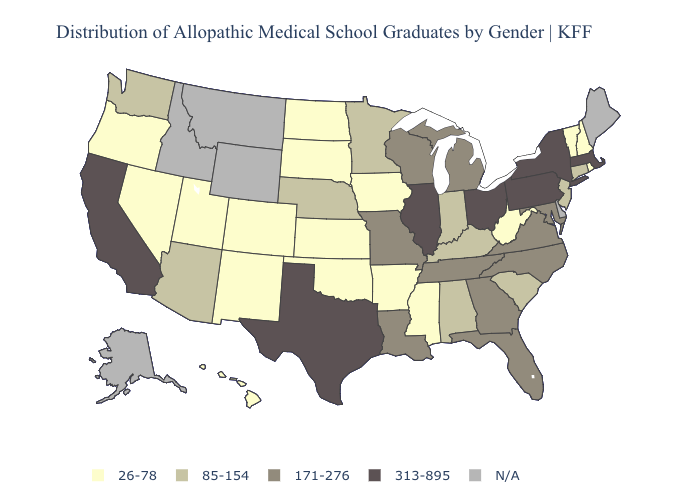What is the value of Michigan?
Short answer required. 171-276. Among the states that border Michigan , does Ohio have the highest value?
Give a very brief answer. Yes. What is the highest value in states that border New Hampshire?
Be succinct. 313-895. Name the states that have a value in the range N/A?
Quick response, please. Alaska, Delaware, Idaho, Maine, Montana, Wyoming. What is the lowest value in states that border Nebraska?
Short answer required. 26-78. Does New Jersey have the lowest value in the USA?
Concise answer only. No. What is the lowest value in the USA?
Write a very short answer. 26-78. What is the value of California?
Quick response, please. 313-895. Name the states that have a value in the range 26-78?
Answer briefly. Arkansas, Colorado, Hawaii, Iowa, Kansas, Mississippi, Nevada, New Hampshire, New Mexico, North Dakota, Oklahoma, Oregon, Rhode Island, South Dakota, Utah, Vermont, West Virginia. Name the states that have a value in the range N/A?
Be succinct. Alaska, Delaware, Idaho, Maine, Montana, Wyoming. Name the states that have a value in the range 171-276?
Quick response, please. Florida, Georgia, Louisiana, Maryland, Michigan, Missouri, North Carolina, Tennessee, Virginia, Wisconsin. What is the value of North Dakota?
Short answer required. 26-78. What is the value of Montana?
Concise answer only. N/A. Does Kansas have the lowest value in the MidWest?
Answer briefly. Yes. 